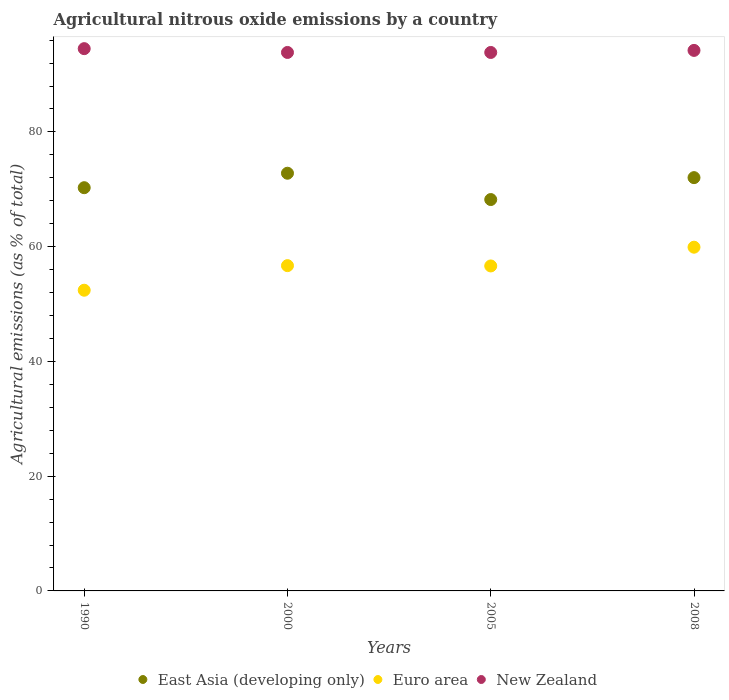How many different coloured dotlines are there?
Keep it short and to the point. 3. Is the number of dotlines equal to the number of legend labels?
Your response must be concise. Yes. What is the amount of agricultural nitrous oxide emitted in East Asia (developing only) in 2008?
Ensure brevity in your answer.  72.03. Across all years, what is the maximum amount of agricultural nitrous oxide emitted in East Asia (developing only)?
Keep it short and to the point. 72.8. Across all years, what is the minimum amount of agricultural nitrous oxide emitted in Euro area?
Your answer should be very brief. 52.41. In which year was the amount of agricultural nitrous oxide emitted in East Asia (developing only) maximum?
Your response must be concise. 2000. In which year was the amount of agricultural nitrous oxide emitted in Euro area minimum?
Make the answer very short. 1990. What is the total amount of agricultural nitrous oxide emitted in Euro area in the graph?
Provide a succinct answer. 225.64. What is the difference between the amount of agricultural nitrous oxide emitted in Euro area in 2005 and that in 2008?
Offer a very short reply. -3.27. What is the difference between the amount of agricultural nitrous oxide emitted in East Asia (developing only) in 1990 and the amount of agricultural nitrous oxide emitted in Euro area in 2008?
Provide a short and direct response. 10.37. What is the average amount of agricultural nitrous oxide emitted in Euro area per year?
Offer a very short reply. 56.41. In the year 1990, what is the difference between the amount of agricultural nitrous oxide emitted in Euro area and amount of agricultural nitrous oxide emitted in East Asia (developing only)?
Offer a very short reply. -17.87. In how many years, is the amount of agricultural nitrous oxide emitted in New Zealand greater than 36 %?
Offer a terse response. 4. What is the ratio of the amount of agricultural nitrous oxide emitted in New Zealand in 2000 to that in 2008?
Make the answer very short. 1. Is the difference between the amount of agricultural nitrous oxide emitted in Euro area in 1990 and 2000 greater than the difference between the amount of agricultural nitrous oxide emitted in East Asia (developing only) in 1990 and 2000?
Your answer should be very brief. No. What is the difference between the highest and the second highest amount of agricultural nitrous oxide emitted in East Asia (developing only)?
Ensure brevity in your answer.  0.77. What is the difference between the highest and the lowest amount of agricultural nitrous oxide emitted in New Zealand?
Offer a terse response. 0.66. In how many years, is the amount of agricultural nitrous oxide emitted in East Asia (developing only) greater than the average amount of agricultural nitrous oxide emitted in East Asia (developing only) taken over all years?
Your answer should be very brief. 2. Is the sum of the amount of agricultural nitrous oxide emitted in Euro area in 2005 and 2008 greater than the maximum amount of agricultural nitrous oxide emitted in East Asia (developing only) across all years?
Your answer should be very brief. Yes. Is it the case that in every year, the sum of the amount of agricultural nitrous oxide emitted in East Asia (developing only) and amount of agricultural nitrous oxide emitted in New Zealand  is greater than the amount of agricultural nitrous oxide emitted in Euro area?
Offer a terse response. Yes. Is the amount of agricultural nitrous oxide emitted in New Zealand strictly greater than the amount of agricultural nitrous oxide emitted in East Asia (developing only) over the years?
Your answer should be compact. Yes. How many years are there in the graph?
Your answer should be very brief. 4. What is the difference between two consecutive major ticks on the Y-axis?
Make the answer very short. 20. Are the values on the major ticks of Y-axis written in scientific E-notation?
Provide a succinct answer. No. Where does the legend appear in the graph?
Provide a short and direct response. Bottom center. What is the title of the graph?
Make the answer very short. Agricultural nitrous oxide emissions by a country. Does "Iceland" appear as one of the legend labels in the graph?
Offer a terse response. No. What is the label or title of the Y-axis?
Give a very brief answer. Agricultural emissions (as % of total). What is the Agricultural emissions (as % of total) of East Asia (developing only) in 1990?
Ensure brevity in your answer.  70.28. What is the Agricultural emissions (as % of total) of Euro area in 1990?
Your answer should be compact. 52.41. What is the Agricultural emissions (as % of total) in New Zealand in 1990?
Provide a succinct answer. 94.51. What is the Agricultural emissions (as % of total) in East Asia (developing only) in 2000?
Make the answer very short. 72.8. What is the Agricultural emissions (as % of total) of Euro area in 2000?
Offer a very short reply. 56.69. What is the Agricultural emissions (as % of total) of New Zealand in 2000?
Give a very brief answer. 93.85. What is the Agricultural emissions (as % of total) of East Asia (developing only) in 2005?
Your response must be concise. 68.21. What is the Agricultural emissions (as % of total) in Euro area in 2005?
Give a very brief answer. 56.64. What is the Agricultural emissions (as % of total) of New Zealand in 2005?
Your answer should be compact. 93.85. What is the Agricultural emissions (as % of total) in East Asia (developing only) in 2008?
Provide a short and direct response. 72.03. What is the Agricultural emissions (as % of total) of Euro area in 2008?
Provide a succinct answer. 59.91. What is the Agricultural emissions (as % of total) in New Zealand in 2008?
Offer a terse response. 94.21. Across all years, what is the maximum Agricultural emissions (as % of total) in East Asia (developing only)?
Provide a short and direct response. 72.8. Across all years, what is the maximum Agricultural emissions (as % of total) in Euro area?
Keep it short and to the point. 59.91. Across all years, what is the maximum Agricultural emissions (as % of total) in New Zealand?
Keep it short and to the point. 94.51. Across all years, what is the minimum Agricultural emissions (as % of total) in East Asia (developing only)?
Your answer should be very brief. 68.21. Across all years, what is the minimum Agricultural emissions (as % of total) of Euro area?
Your answer should be very brief. 52.41. Across all years, what is the minimum Agricultural emissions (as % of total) in New Zealand?
Make the answer very short. 93.85. What is the total Agricultural emissions (as % of total) of East Asia (developing only) in the graph?
Offer a terse response. 283.32. What is the total Agricultural emissions (as % of total) in Euro area in the graph?
Your answer should be very brief. 225.64. What is the total Agricultural emissions (as % of total) in New Zealand in the graph?
Your answer should be compact. 376.41. What is the difference between the Agricultural emissions (as % of total) of East Asia (developing only) in 1990 and that in 2000?
Provide a short and direct response. -2.52. What is the difference between the Agricultural emissions (as % of total) in Euro area in 1990 and that in 2000?
Provide a short and direct response. -4.28. What is the difference between the Agricultural emissions (as % of total) in New Zealand in 1990 and that in 2000?
Give a very brief answer. 0.66. What is the difference between the Agricultural emissions (as % of total) in East Asia (developing only) in 1990 and that in 2005?
Make the answer very short. 2.07. What is the difference between the Agricultural emissions (as % of total) in Euro area in 1990 and that in 2005?
Provide a succinct answer. -4.23. What is the difference between the Agricultural emissions (as % of total) in New Zealand in 1990 and that in 2005?
Offer a very short reply. 0.66. What is the difference between the Agricultural emissions (as % of total) of East Asia (developing only) in 1990 and that in 2008?
Make the answer very short. -1.75. What is the difference between the Agricultural emissions (as % of total) of Euro area in 1990 and that in 2008?
Your answer should be very brief. -7.5. What is the difference between the Agricultural emissions (as % of total) of New Zealand in 1990 and that in 2008?
Keep it short and to the point. 0.3. What is the difference between the Agricultural emissions (as % of total) in East Asia (developing only) in 2000 and that in 2005?
Your answer should be compact. 4.59. What is the difference between the Agricultural emissions (as % of total) in Euro area in 2000 and that in 2005?
Your answer should be very brief. 0.05. What is the difference between the Agricultural emissions (as % of total) of New Zealand in 2000 and that in 2005?
Give a very brief answer. 0. What is the difference between the Agricultural emissions (as % of total) of East Asia (developing only) in 2000 and that in 2008?
Make the answer very short. 0.77. What is the difference between the Agricultural emissions (as % of total) of Euro area in 2000 and that in 2008?
Your answer should be compact. -3.21. What is the difference between the Agricultural emissions (as % of total) of New Zealand in 2000 and that in 2008?
Your answer should be very brief. -0.36. What is the difference between the Agricultural emissions (as % of total) in East Asia (developing only) in 2005 and that in 2008?
Make the answer very short. -3.82. What is the difference between the Agricultural emissions (as % of total) of Euro area in 2005 and that in 2008?
Provide a succinct answer. -3.27. What is the difference between the Agricultural emissions (as % of total) of New Zealand in 2005 and that in 2008?
Keep it short and to the point. -0.36. What is the difference between the Agricultural emissions (as % of total) in East Asia (developing only) in 1990 and the Agricultural emissions (as % of total) in Euro area in 2000?
Keep it short and to the point. 13.58. What is the difference between the Agricultural emissions (as % of total) in East Asia (developing only) in 1990 and the Agricultural emissions (as % of total) in New Zealand in 2000?
Give a very brief answer. -23.57. What is the difference between the Agricultural emissions (as % of total) in Euro area in 1990 and the Agricultural emissions (as % of total) in New Zealand in 2000?
Provide a succinct answer. -41.44. What is the difference between the Agricultural emissions (as % of total) in East Asia (developing only) in 1990 and the Agricultural emissions (as % of total) in Euro area in 2005?
Your answer should be compact. 13.64. What is the difference between the Agricultural emissions (as % of total) in East Asia (developing only) in 1990 and the Agricultural emissions (as % of total) in New Zealand in 2005?
Provide a short and direct response. -23.57. What is the difference between the Agricultural emissions (as % of total) in Euro area in 1990 and the Agricultural emissions (as % of total) in New Zealand in 2005?
Keep it short and to the point. -41.44. What is the difference between the Agricultural emissions (as % of total) in East Asia (developing only) in 1990 and the Agricultural emissions (as % of total) in Euro area in 2008?
Make the answer very short. 10.37. What is the difference between the Agricultural emissions (as % of total) in East Asia (developing only) in 1990 and the Agricultural emissions (as % of total) in New Zealand in 2008?
Ensure brevity in your answer.  -23.93. What is the difference between the Agricultural emissions (as % of total) in Euro area in 1990 and the Agricultural emissions (as % of total) in New Zealand in 2008?
Keep it short and to the point. -41.8. What is the difference between the Agricultural emissions (as % of total) in East Asia (developing only) in 2000 and the Agricultural emissions (as % of total) in Euro area in 2005?
Your response must be concise. 16.16. What is the difference between the Agricultural emissions (as % of total) in East Asia (developing only) in 2000 and the Agricultural emissions (as % of total) in New Zealand in 2005?
Provide a succinct answer. -21.05. What is the difference between the Agricultural emissions (as % of total) in Euro area in 2000 and the Agricultural emissions (as % of total) in New Zealand in 2005?
Provide a succinct answer. -37.15. What is the difference between the Agricultural emissions (as % of total) of East Asia (developing only) in 2000 and the Agricultural emissions (as % of total) of Euro area in 2008?
Your response must be concise. 12.89. What is the difference between the Agricultural emissions (as % of total) in East Asia (developing only) in 2000 and the Agricultural emissions (as % of total) in New Zealand in 2008?
Offer a very short reply. -21.41. What is the difference between the Agricultural emissions (as % of total) in Euro area in 2000 and the Agricultural emissions (as % of total) in New Zealand in 2008?
Your response must be concise. -37.51. What is the difference between the Agricultural emissions (as % of total) of East Asia (developing only) in 2005 and the Agricultural emissions (as % of total) of Euro area in 2008?
Offer a very short reply. 8.31. What is the difference between the Agricultural emissions (as % of total) in East Asia (developing only) in 2005 and the Agricultural emissions (as % of total) in New Zealand in 2008?
Give a very brief answer. -25.99. What is the difference between the Agricultural emissions (as % of total) of Euro area in 2005 and the Agricultural emissions (as % of total) of New Zealand in 2008?
Keep it short and to the point. -37.57. What is the average Agricultural emissions (as % of total) of East Asia (developing only) per year?
Provide a succinct answer. 70.83. What is the average Agricultural emissions (as % of total) of Euro area per year?
Offer a very short reply. 56.41. What is the average Agricultural emissions (as % of total) in New Zealand per year?
Make the answer very short. 94.1. In the year 1990, what is the difference between the Agricultural emissions (as % of total) of East Asia (developing only) and Agricultural emissions (as % of total) of Euro area?
Give a very brief answer. 17.87. In the year 1990, what is the difference between the Agricultural emissions (as % of total) in East Asia (developing only) and Agricultural emissions (as % of total) in New Zealand?
Offer a terse response. -24.23. In the year 1990, what is the difference between the Agricultural emissions (as % of total) of Euro area and Agricultural emissions (as % of total) of New Zealand?
Your answer should be compact. -42.1. In the year 2000, what is the difference between the Agricultural emissions (as % of total) in East Asia (developing only) and Agricultural emissions (as % of total) in Euro area?
Your answer should be very brief. 16.11. In the year 2000, what is the difference between the Agricultural emissions (as % of total) in East Asia (developing only) and Agricultural emissions (as % of total) in New Zealand?
Give a very brief answer. -21.05. In the year 2000, what is the difference between the Agricultural emissions (as % of total) in Euro area and Agricultural emissions (as % of total) in New Zealand?
Make the answer very short. -37.16. In the year 2005, what is the difference between the Agricultural emissions (as % of total) in East Asia (developing only) and Agricultural emissions (as % of total) in Euro area?
Offer a very short reply. 11.57. In the year 2005, what is the difference between the Agricultural emissions (as % of total) of East Asia (developing only) and Agricultural emissions (as % of total) of New Zealand?
Provide a short and direct response. -25.64. In the year 2005, what is the difference between the Agricultural emissions (as % of total) in Euro area and Agricultural emissions (as % of total) in New Zealand?
Ensure brevity in your answer.  -37.21. In the year 2008, what is the difference between the Agricultural emissions (as % of total) of East Asia (developing only) and Agricultural emissions (as % of total) of Euro area?
Provide a short and direct response. 12.12. In the year 2008, what is the difference between the Agricultural emissions (as % of total) of East Asia (developing only) and Agricultural emissions (as % of total) of New Zealand?
Provide a succinct answer. -22.18. In the year 2008, what is the difference between the Agricultural emissions (as % of total) in Euro area and Agricultural emissions (as % of total) in New Zealand?
Offer a terse response. -34.3. What is the ratio of the Agricultural emissions (as % of total) of East Asia (developing only) in 1990 to that in 2000?
Keep it short and to the point. 0.97. What is the ratio of the Agricultural emissions (as % of total) of Euro area in 1990 to that in 2000?
Offer a very short reply. 0.92. What is the ratio of the Agricultural emissions (as % of total) of New Zealand in 1990 to that in 2000?
Offer a terse response. 1.01. What is the ratio of the Agricultural emissions (as % of total) of East Asia (developing only) in 1990 to that in 2005?
Keep it short and to the point. 1.03. What is the ratio of the Agricultural emissions (as % of total) of Euro area in 1990 to that in 2005?
Ensure brevity in your answer.  0.93. What is the ratio of the Agricultural emissions (as % of total) of New Zealand in 1990 to that in 2005?
Offer a terse response. 1.01. What is the ratio of the Agricultural emissions (as % of total) in East Asia (developing only) in 1990 to that in 2008?
Offer a terse response. 0.98. What is the ratio of the Agricultural emissions (as % of total) in Euro area in 1990 to that in 2008?
Make the answer very short. 0.87. What is the ratio of the Agricultural emissions (as % of total) of East Asia (developing only) in 2000 to that in 2005?
Provide a short and direct response. 1.07. What is the ratio of the Agricultural emissions (as % of total) of New Zealand in 2000 to that in 2005?
Make the answer very short. 1. What is the ratio of the Agricultural emissions (as % of total) in East Asia (developing only) in 2000 to that in 2008?
Ensure brevity in your answer.  1.01. What is the ratio of the Agricultural emissions (as % of total) of Euro area in 2000 to that in 2008?
Provide a short and direct response. 0.95. What is the ratio of the Agricultural emissions (as % of total) in East Asia (developing only) in 2005 to that in 2008?
Offer a terse response. 0.95. What is the ratio of the Agricultural emissions (as % of total) in Euro area in 2005 to that in 2008?
Your answer should be very brief. 0.95. What is the difference between the highest and the second highest Agricultural emissions (as % of total) in East Asia (developing only)?
Offer a very short reply. 0.77. What is the difference between the highest and the second highest Agricultural emissions (as % of total) of Euro area?
Offer a terse response. 3.21. What is the difference between the highest and the second highest Agricultural emissions (as % of total) of New Zealand?
Your response must be concise. 0.3. What is the difference between the highest and the lowest Agricultural emissions (as % of total) in East Asia (developing only)?
Your response must be concise. 4.59. What is the difference between the highest and the lowest Agricultural emissions (as % of total) of Euro area?
Ensure brevity in your answer.  7.5. What is the difference between the highest and the lowest Agricultural emissions (as % of total) of New Zealand?
Your answer should be compact. 0.66. 